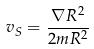<formula> <loc_0><loc_0><loc_500><loc_500>v _ { S } = \frac { \nabla R ^ { 2 } } { 2 m R ^ { 2 } }</formula> 